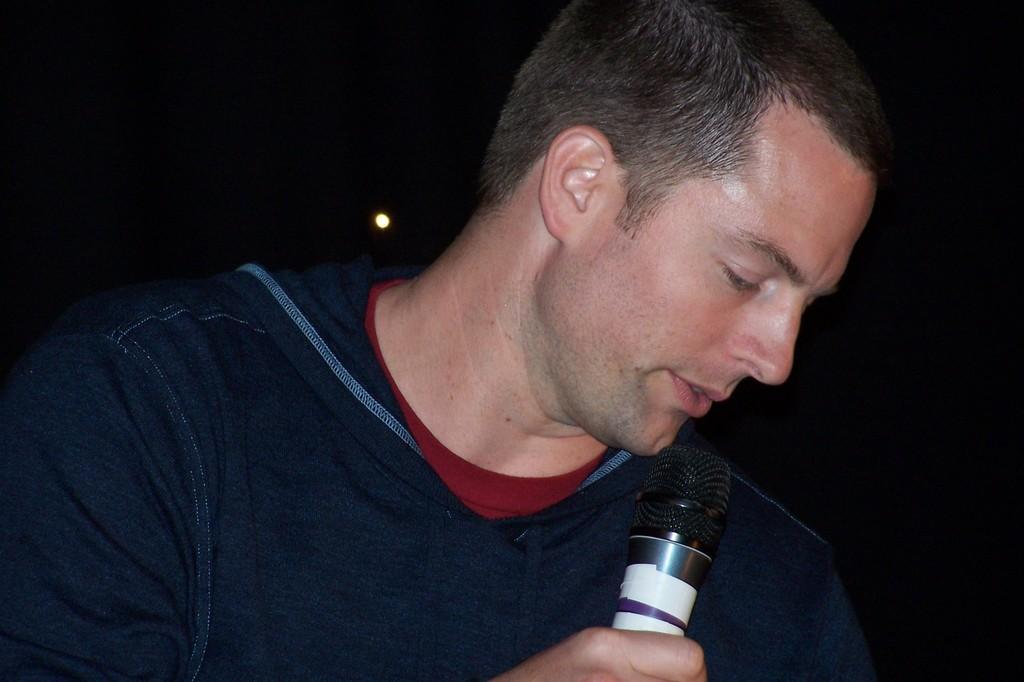How would you summarize this image in a sentence or two? Here we can see a man with a t shirt holding a microphone in his right hand and he is talking. 